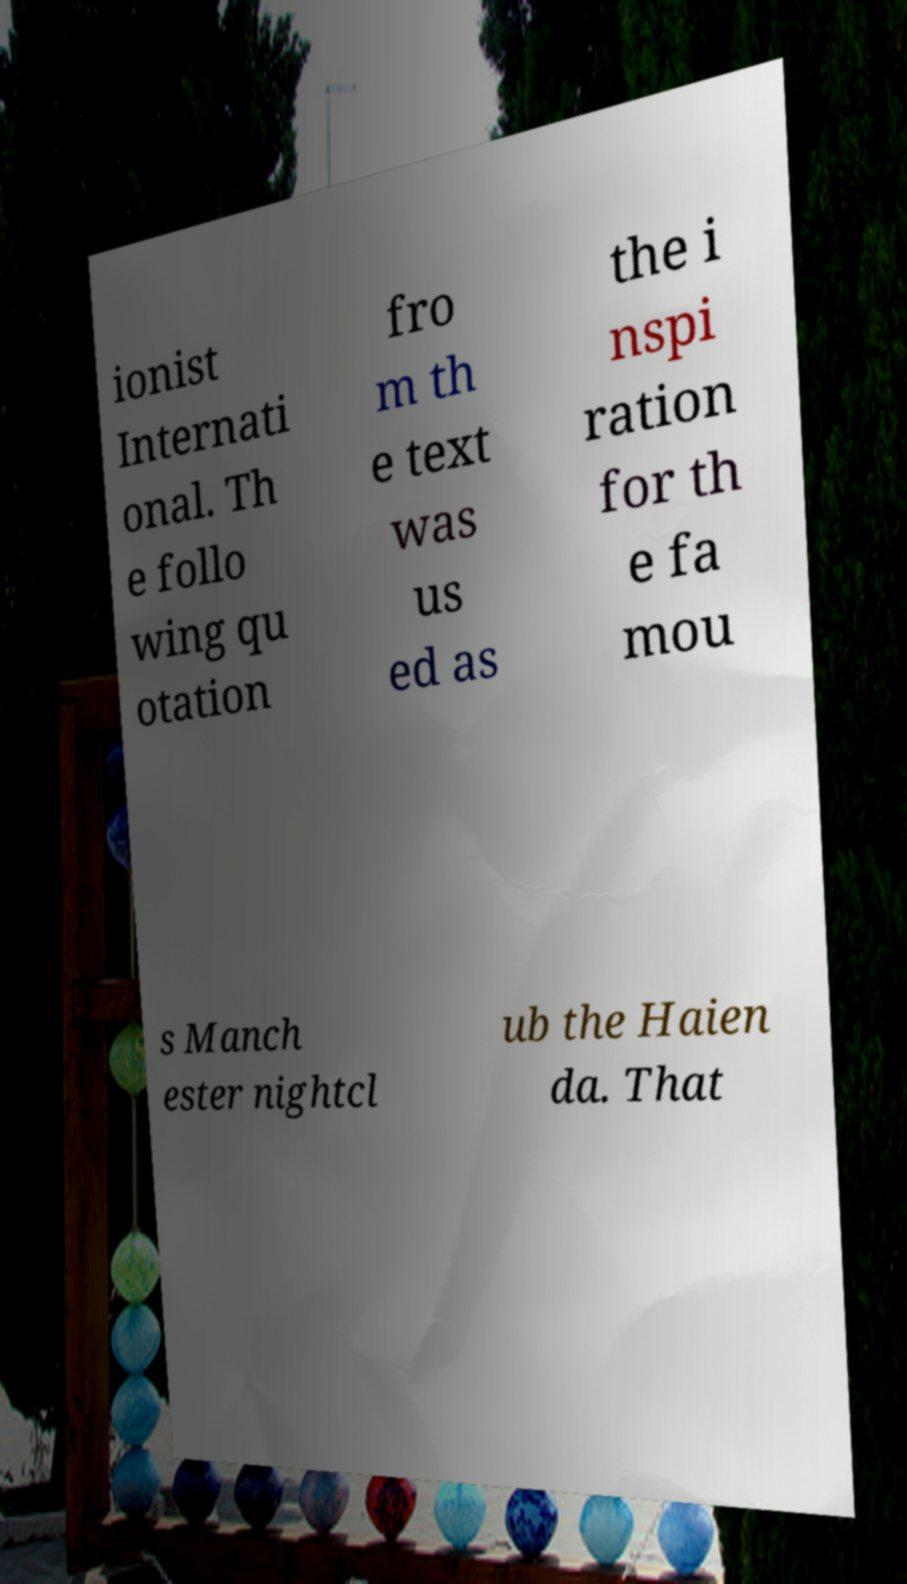Please identify and transcribe the text found in this image. ionist Internati onal. Th e follo wing qu otation fro m th e text was us ed as the i nspi ration for th e fa mou s Manch ester nightcl ub the Haien da. That 